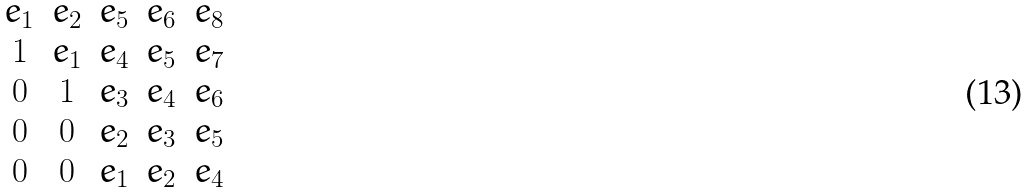Convert formula to latex. <formula><loc_0><loc_0><loc_500><loc_500>\begin{matrix} e _ { 1 } & e _ { 2 } & e _ { 5 } & e _ { 6 } & e _ { 8 } \\ 1 & e _ { 1 } & e _ { 4 } & e _ { 5 } & e _ { 7 } \\ 0 & 1 & e _ { 3 } & e _ { 4 } & e _ { 6 } \\ 0 & 0 & e _ { 2 } & e _ { 3 } & e _ { 5 } \\ 0 & 0 & e _ { 1 } & e _ { 2 } & e _ { 4 } \end{matrix}</formula> 